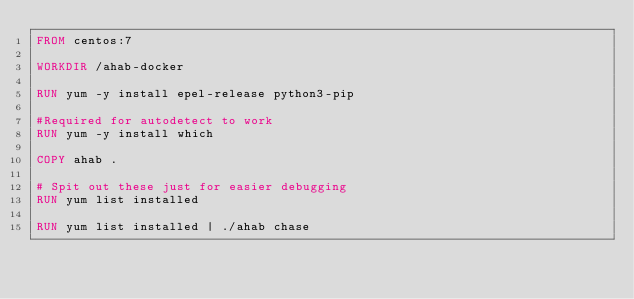Convert code to text. <code><loc_0><loc_0><loc_500><loc_500><_Dockerfile_>FROM centos:7

WORKDIR /ahab-docker

RUN yum -y install epel-release python3-pip

#Required for autodetect to work
RUN yum -y install which

COPY ahab .

# Spit out these just for easier debugging
RUN yum list installed

RUN yum list installed | ./ahab chase

</code> 